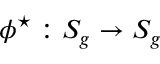<formula> <loc_0><loc_0><loc_500><loc_500>{ \phi ^ { ^ { * } } \colon S _ { g } \rightarrow S _ { g } }</formula> 